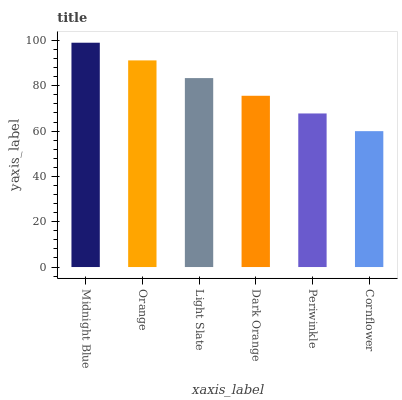Is Orange the minimum?
Answer yes or no. No. Is Orange the maximum?
Answer yes or no. No. Is Midnight Blue greater than Orange?
Answer yes or no. Yes. Is Orange less than Midnight Blue?
Answer yes or no. Yes. Is Orange greater than Midnight Blue?
Answer yes or no. No. Is Midnight Blue less than Orange?
Answer yes or no. No. Is Light Slate the high median?
Answer yes or no. Yes. Is Dark Orange the low median?
Answer yes or no. Yes. Is Orange the high median?
Answer yes or no. No. Is Midnight Blue the low median?
Answer yes or no. No. 